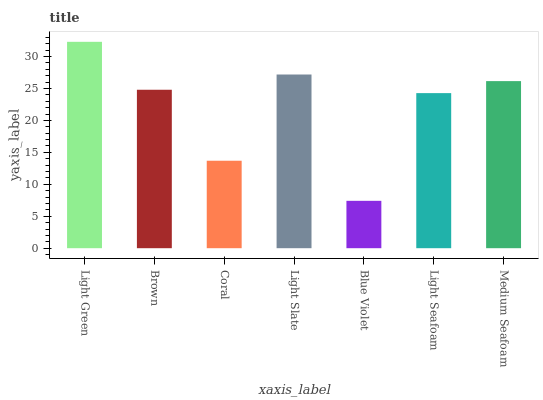Is Blue Violet the minimum?
Answer yes or no. Yes. Is Light Green the maximum?
Answer yes or no. Yes. Is Brown the minimum?
Answer yes or no. No. Is Brown the maximum?
Answer yes or no. No. Is Light Green greater than Brown?
Answer yes or no. Yes. Is Brown less than Light Green?
Answer yes or no. Yes. Is Brown greater than Light Green?
Answer yes or no. No. Is Light Green less than Brown?
Answer yes or no. No. Is Brown the high median?
Answer yes or no. Yes. Is Brown the low median?
Answer yes or no. Yes. Is Blue Violet the high median?
Answer yes or no. No. Is Light Green the low median?
Answer yes or no. No. 